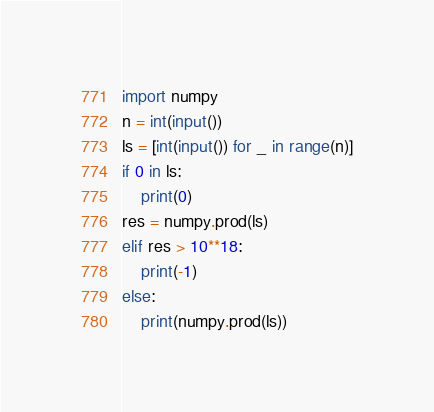<code> <loc_0><loc_0><loc_500><loc_500><_Python_>import numpy
n = int(input())
ls = [int(input()) for _ in range(n)]
if 0 in ls:
    print(0)
res = numpy.prod(ls)
elif res > 10**18:
    print(-1)
else:
    print(numpy.prod(ls))
</code> 